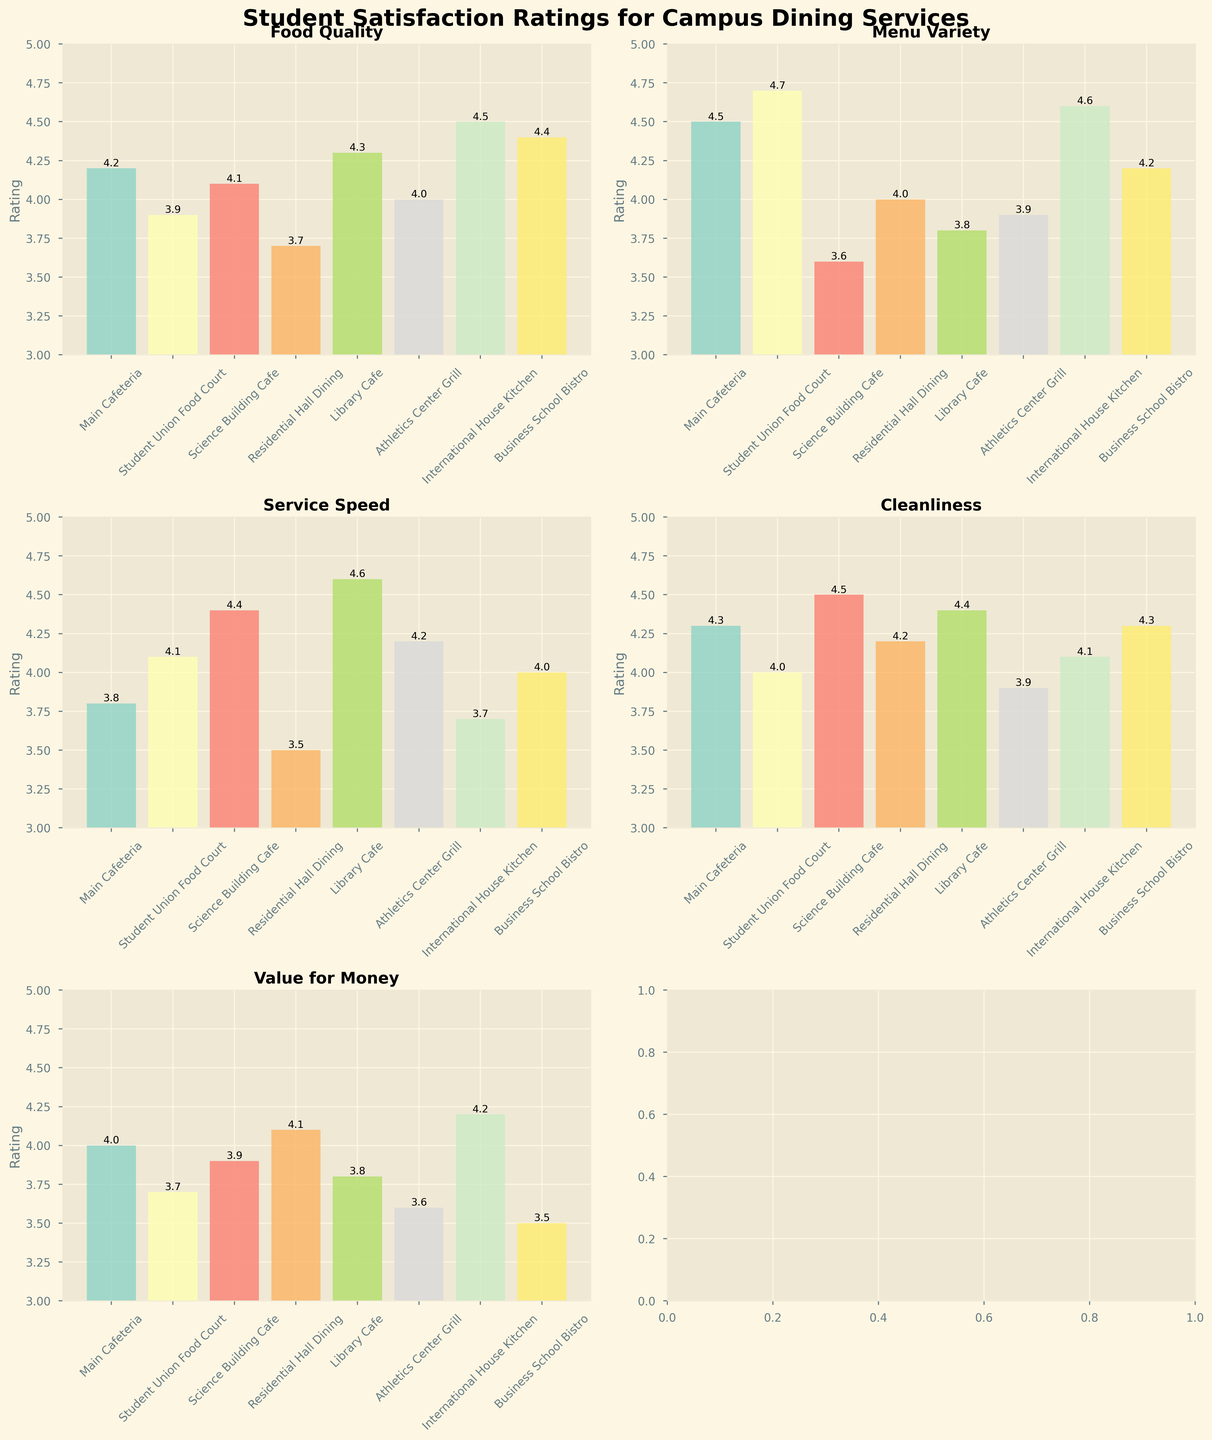What's the title of the figure? The title of the figure is typically found at the top and provides a concise description of what the figure is about. Here, it says "Student Satisfaction Ratings for Campus Dining Services".
Answer: Student Satisfaction Ratings for Campus Dining Services Which location received the highest rating for Food Quality? By inspecting the bar heights under the "Food Quality" subplot, International House Kitchen received the highest rating since it has the tallest bar.
Answer: International House Kitchen What is the average Cleanliness rating across all locations? To determine the average, add up all the Cleanliness ratings and divide by the number of locations. The Cleanliness ratings are 4.3, 4.0, 4.5, 4.2, 4.4, 3.9, 4.1, and 4.3. The sum is 33.7, and with 8 locations, the average is 33.7 / 8.
Answer: 4.21 Compare the Service Speed ratings of Main Cafeteria and Library Cafe. Which one is higher? Look at the "Service Speed" subplot to identify the heights of the bars for both Main Cafeteria and Library Cafe. Library Cafe's bar is higher than Main Cafeteria's.
Answer: Library Cafe Which location has the lowest 'Value for Money' rating, and what is the rating? In the "Value for Money" subplot, the shortest bar indicates the lowest rating. The Business School Bistro has the lowest bar with a rating of 3.5.
Answer: Business School Bistro, 3.5 How does the 'Menu Variety' rating for Student Union Food Court compare to Science Building Cafe? In the "Menu Variety" subplot, observe the heights of the bars for both locations. Student Union Food Court has a rating of 4.7, and Science Building Cafe has a rating of 3.6.
Answer: Student Union Food Court is higher What is the range of Food Quality ratings across all locations? The range is calculated by subtracting the lowest rating from the highest rating. Food Quality ratings range from 3.7 (Residential Hall Dining) to 4.5 (International House Kitchen), so the range is 4.5 - 3.7.
Answer: 0.8 How many locations have a Service Speed rating above 4.0? Count the bars in the "Service Speed" subplot that exceed the 4.0 mark. There are 5 locations: Science Building Cafe, Library Cafe, Student Union Food Court, Athletics Center Grill, and Business School Bistro.
Answer: 5 What is the difference in 'Cleanliness' rating between the highest-rated and the lowest-rated locations? Identify the highest and lowest bars in the "Cleanliness" subplot. The highest rating is 4.5 (Science Building Cafe), and the lowest is 3.9 (Athletics Center Grill). The difference is 4.5 - 3.9.
Answer: 0.6 